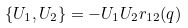Convert formula to latex. <formula><loc_0><loc_0><loc_500><loc_500>\{ U _ { 1 } , U _ { 2 } \} = - U _ { 1 } U _ { 2 } r _ { 1 2 } ( q )</formula> 